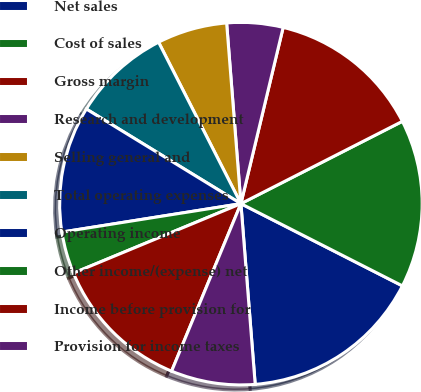Convert chart to OTSL. <chart><loc_0><loc_0><loc_500><loc_500><pie_chart><fcel>Net sales<fcel>Cost of sales<fcel>Gross margin<fcel>Research and development<fcel>Selling general and<fcel>Total operating expenses<fcel>Operating income<fcel>Other income/(expense) net<fcel>Income before provision for<fcel>Provision for income taxes<nl><fcel>16.25%<fcel>15.0%<fcel>13.75%<fcel>5.0%<fcel>6.25%<fcel>8.75%<fcel>11.25%<fcel>3.75%<fcel>12.5%<fcel>7.5%<nl></chart> 